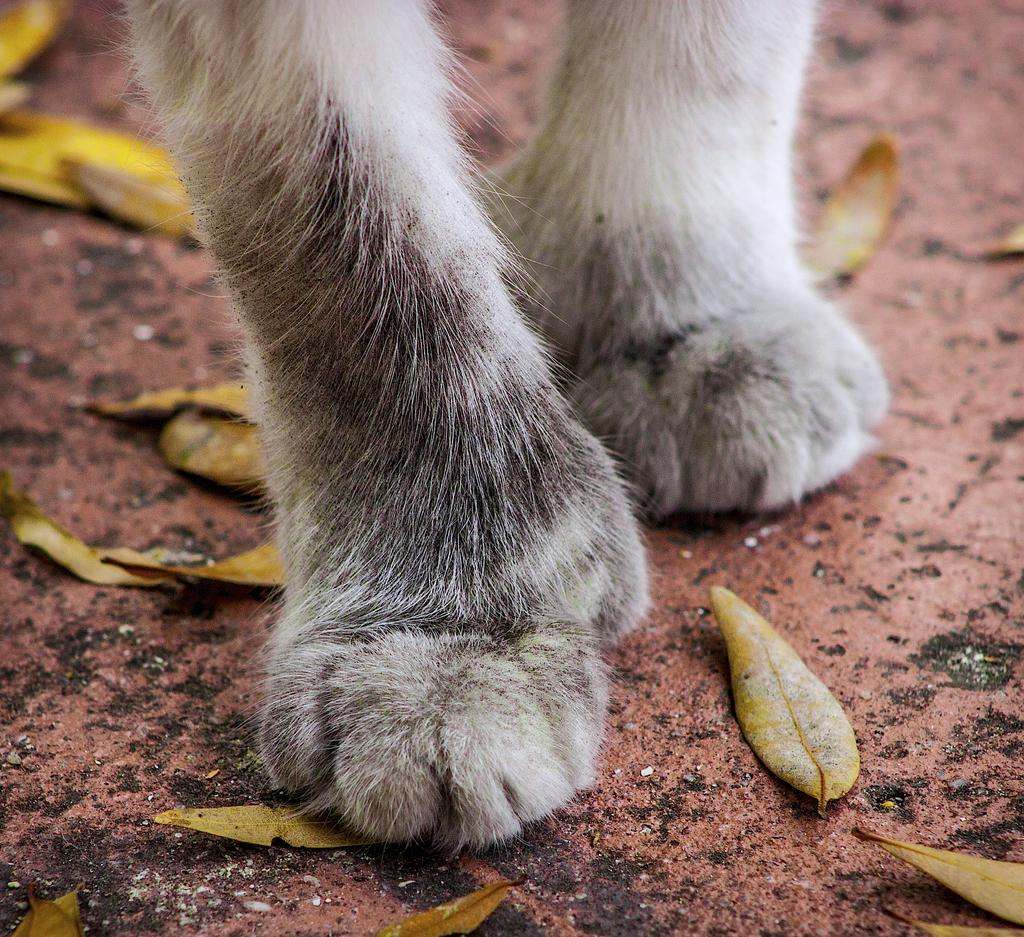What is the main subject in the center of the image? There is an animal foot in the center of the image. What color is the animal foot? The animal foot is white in color. What type of vegetation can be seen in the image? There are leaves visible in the image. Are there any other objects present in the image besides the animal foot and leaves? Yes, there are a few other objects in the image. What type of map is the governor holding in the image? There is no map or governor present in the image; it features an animal foot and leaves. How many babies are visible in the image? There are no babies present in the image. 